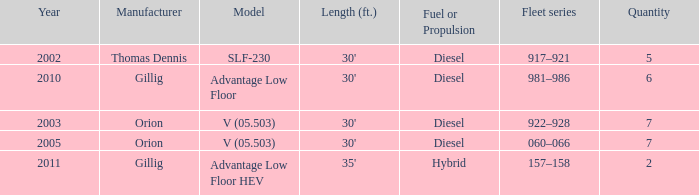Tell me the model with fuel or propulsion of diesel and orion manufacturer in 2005 V (05.503). 